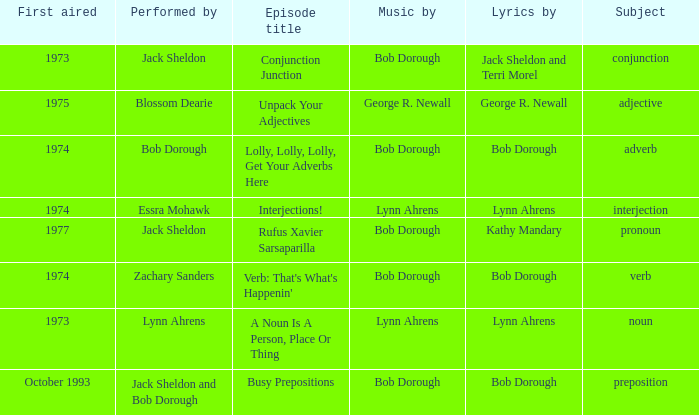Can you give me this table as a dict? {'header': ['First aired', 'Performed by', 'Episode title', 'Music by', 'Lyrics by', 'Subject'], 'rows': [['1973', 'Jack Sheldon', 'Conjunction Junction', 'Bob Dorough', 'Jack Sheldon and Terri Morel', 'conjunction'], ['1975', 'Blossom Dearie', 'Unpack Your Adjectives', 'George R. Newall', 'George R. Newall', 'adjective'], ['1974', 'Bob Dorough', 'Lolly, Lolly, Lolly, Get Your Adverbs Here', 'Bob Dorough', 'Bob Dorough', 'adverb'], ['1974', 'Essra Mohawk', 'Interjections!', 'Lynn Ahrens', 'Lynn Ahrens', 'interjection'], ['1977', 'Jack Sheldon', 'Rufus Xavier Sarsaparilla', 'Bob Dorough', 'Kathy Mandary', 'pronoun'], ['1974', 'Zachary Sanders', "Verb: That's What's Happenin'", 'Bob Dorough', 'Bob Dorough', 'verb'], ['1973', 'Lynn Ahrens', 'A Noun Is A Person, Place Or Thing', 'Lynn Ahrens', 'Lynn Ahrens', 'noun'], ['October 1993', 'Jack Sheldon and Bob Dorough', 'Busy Prepositions', 'Bob Dorough', 'Bob Dorough', 'preposition']]} How many first aired episodes are there when zachary sanders is the performer? 1.0. 